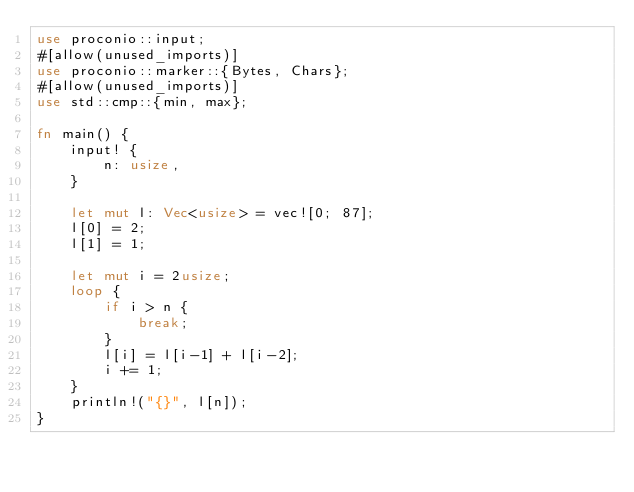Convert code to text. <code><loc_0><loc_0><loc_500><loc_500><_Rust_>use proconio::input;
#[allow(unused_imports)]
use proconio::marker::{Bytes, Chars};
#[allow(unused_imports)]
use std::cmp::{min, max};

fn main() {
	input! {
		n: usize,
	}

	let mut l: Vec<usize> = vec![0; 87];
	l[0] = 2;
	l[1] = 1;

	let mut i = 2usize;
	loop {
		if i > n {
			break;
		}
		l[i] = l[i-1] + l[i-2];
		i += 1;
	}
	println!("{}", l[n]);
}

</code> 